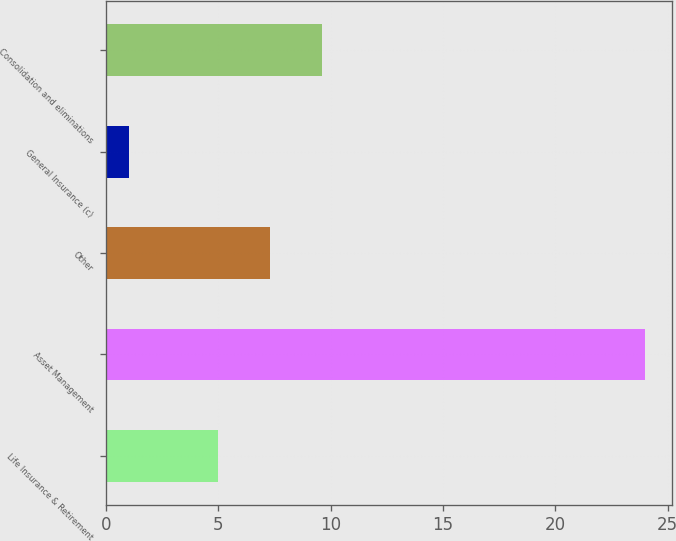<chart> <loc_0><loc_0><loc_500><loc_500><bar_chart><fcel>Life Insurance & Retirement<fcel>Asset Management<fcel>Other<fcel>General Insurance (c)<fcel>Consolidation and eliminations<nl><fcel>5<fcel>24<fcel>7.3<fcel>1<fcel>9.6<nl></chart> 